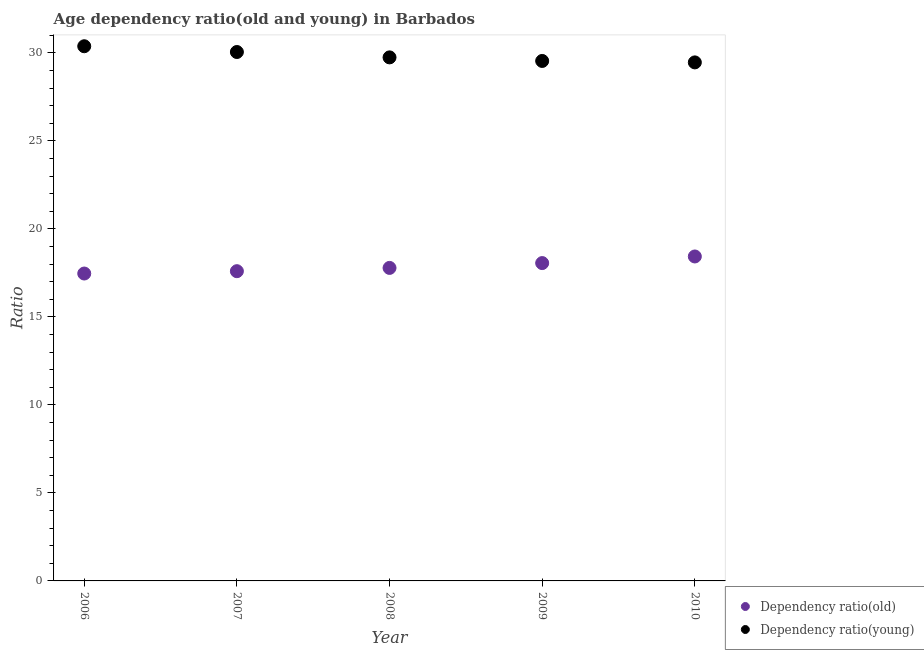Is the number of dotlines equal to the number of legend labels?
Ensure brevity in your answer.  Yes. What is the age dependency ratio(old) in 2009?
Your answer should be compact. 18.06. Across all years, what is the maximum age dependency ratio(young)?
Ensure brevity in your answer.  30.38. Across all years, what is the minimum age dependency ratio(young)?
Offer a very short reply. 29.46. What is the total age dependency ratio(old) in the graph?
Keep it short and to the point. 89.34. What is the difference between the age dependency ratio(young) in 2006 and that in 2010?
Ensure brevity in your answer.  0.92. What is the difference between the age dependency ratio(old) in 2010 and the age dependency ratio(young) in 2006?
Your answer should be compact. -11.94. What is the average age dependency ratio(old) per year?
Make the answer very short. 17.87. In the year 2009, what is the difference between the age dependency ratio(old) and age dependency ratio(young)?
Offer a terse response. -11.48. What is the ratio of the age dependency ratio(young) in 2007 to that in 2010?
Ensure brevity in your answer.  1.02. What is the difference between the highest and the second highest age dependency ratio(old)?
Your answer should be very brief. 0.38. What is the difference between the highest and the lowest age dependency ratio(old)?
Your answer should be compact. 0.97. Is the sum of the age dependency ratio(old) in 2006 and 2008 greater than the maximum age dependency ratio(young) across all years?
Provide a succinct answer. Yes. Does the age dependency ratio(old) monotonically increase over the years?
Your response must be concise. Yes. Is the age dependency ratio(old) strictly greater than the age dependency ratio(young) over the years?
Provide a short and direct response. No. Is the age dependency ratio(old) strictly less than the age dependency ratio(young) over the years?
Offer a terse response. Yes. How many years are there in the graph?
Ensure brevity in your answer.  5. What is the difference between two consecutive major ticks on the Y-axis?
Provide a short and direct response. 5. Does the graph contain grids?
Provide a succinct answer. No. How are the legend labels stacked?
Make the answer very short. Vertical. What is the title of the graph?
Provide a short and direct response. Age dependency ratio(old and young) in Barbados. What is the label or title of the Y-axis?
Provide a succinct answer. Ratio. What is the Ratio of Dependency ratio(old) in 2006?
Keep it short and to the point. 17.47. What is the Ratio of Dependency ratio(young) in 2006?
Give a very brief answer. 30.38. What is the Ratio in Dependency ratio(old) in 2007?
Your response must be concise. 17.6. What is the Ratio in Dependency ratio(young) in 2007?
Make the answer very short. 30.05. What is the Ratio of Dependency ratio(old) in 2008?
Keep it short and to the point. 17.78. What is the Ratio of Dependency ratio(young) in 2008?
Your answer should be very brief. 29.75. What is the Ratio in Dependency ratio(old) in 2009?
Provide a succinct answer. 18.06. What is the Ratio of Dependency ratio(young) in 2009?
Offer a terse response. 29.54. What is the Ratio of Dependency ratio(old) in 2010?
Your answer should be compact. 18.43. What is the Ratio in Dependency ratio(young) in 2010?
Provide a short and direct response. 29.46. Across all years, what is the maximum Ratio in Dependency ratio(old)?
Ensure brevity in your answer.  18.43. Across all years, what is the maximum Ratio of Dependency ratio(young)?
Offer a very short reply. 30.38. Across all years, what is the minimum Ratio of Dependency ratio(old)?
Your answer should be compact. 17.47. Across all years, what is the minimum Ratio of Dependency ratio(young)?
Provide a succinct answer. 29.46. What is the total Ratio of Dependency ratio(old) in the graph?
Offer a very short reply. 89.34. What is the total Ratio of Dependency ratio(young) in the graph?
Your answer should be very brief. 149.18. What is the difference between the Ratio in Dependency ratio(old) in 2006 and that in 2007?
Provide a short and direct response. -0.13. What is the difference between the Ratio of Dependency ratio(young) in 2006 and that in 2007?
Your answer should be very brief. 0.33. What is the difference between the Ratio of Dependency ratio(old) in 2006 and that in 2008?
Give a very brief answer. -0.32. What is the difference between the Ratio in Dependency ratio(young) in 2006 and that in 2008?
Your answer should be compact. 0.63. What is the difference between the Ratio in Dependency ratio(old) in 2006 and that in 2009?
Your answer should be compact. -0.59. What is the difference between the Ratio of Dependency ratio(young) in 2006 and that in 2009?
Give a very brief answer. 0.84. What is the difference between the Ratio in Dependency ratio(old) in 2006 and that in 2010?
Offer a terse response. -0.97. What is the difference between the Ratio of Dependency ratio(young) in 2006 and that in 2010?
Provide a short and direct response. 0.92. What is the difference between the Ratio of Dependency ratio(old) in 2007 and that in 2008?
Make the answer very short. -0.19. What is the difference between the Ratio in Dependency ratio(young) in 2007 and that in 2008?
Your answer should be compact. 0.31. What is the difference between the Ratio in Dependency ratio(old) in 2007 and that in 2009?
Offer a very short reply. -0.46. What is the difference between the Ratio of Dependency ratio(young) in 2007 and that in 2009?
Give a very brief answer. 0.51. What is the difference between the Ratio in Dependency ratio(old) in 2007 and that in 2010?
Provide a short and direct response. -0.84. What is the difference between the Ratio in Dependency ratio(young) in 2007 and that in 2010?
Make the answer very short. 0.59. What is the difference between the Ratio in Dependency ratio(old) in 2008 and that in 2009?
Your response must be concise. -0.27. What is the difference between the Ratio in Dependency ratio(young) in 2008 and that in 2009?
Ensure brevity in your answer.  0.2. What is the difference between the Ratio of Dependency ratio(old) in 2008 and that in 2010?
Ensure brevity in your answer.  -0.65. What is the difference between the Ratio of Dependency ratio(young) in 2008 and that in 2010?
Ensure brevity in your answer.  0.28. What is the difference between the Ratio in Dependency ratio(old) in 2009 and that in 2010?
Your answer should be compact. -0.38. What is the difference between the Ratio of Dependency ratio(young) in 2009 and that in 2010?
Offer a terse response. 0.08. What is the difference between the Ratio in Dependency ratio(old) in 2006 and the Ratio in Dependency ratio(young) in 2007?
Make the answer very short. -12.59. What is the difference between the Ratio in Dependency ratio(old) in 2006 and the Ratio in Dependency ratio(young) in 2008?
Your response must be concise. -12.28. What is the difference between the Ratio in Dependency ratio(old) in 2006 and the Ratio in Dependency ratio(young) in 2009?
Offer a terse response. -12.08. What is the difference between the Ratio in Dependency ratio(old) in 2006 and the Ratio in Dependency ratio(young) in 2010?
Provide a succinct answer. -12. What is the difference between the Ratio of Dependency ratio(old) in 2007 and the Ratio of Dependency ratio(young) in 2008?
Keep it short and to the point. -12.15. What is the difference between the Ratio of Dependency ratio(old) in 2007 and the Ratio of Dependency ratio(young) in 2009?
Give a very brief answer. -11.95. What is the difference between the Ratio of Dependency ratio(old) in 2007 and the Ratio of Dependency ratio(young) in 2010?
Keep it short and to the point. -11.86. What is the difference between the Ratio in Dependency ratio(old) in 2008 and the Ratio in Dependency ratio(young) in 2009?
Provide a short and direct response. -11.76. What is the difference between the Ratio of Dependency ratio(old) in 2008 and the Ratio of Dependency ratio(young) in 2010?
Provide a short and direct response. -11.68. What is the difference between the Ratio in Dependency ratio(old) in 2009 and the Ratio in Dependency ratio(young) in 2010?
Ensure brevity in your answer.  -11.4. What is the average Ratio of Dependency ratio(old) per year?
Your answer should be compact. 17.87. What is the average Ratio of Dependency ratio(young) per year?
Offer a terse response. 29.84. In the year 2006, what is the difference between the Ratio in Dependency ratio(old) and Ratio in Dependency ratio(young)?
Offer a very short reply. -12.91. In the year 2007, what is the difference between the Ratio of Dependency ratio(old) and Ratio of Dependency ratio(young)?
Your answer should be compact. -12.45. In the year 2008, what is the difference between the Ratio of Dependency ratio(old) and Ratio of Dependency ratio(young)?
Give a very brief answer. -11.96. In the year 2009, what is the difference between the Ratio of Dependency ratio(old) and Ratio of Dependency ratio(young)?
Your answer should be compact. -11.48. In the year 2010, what is the difference between the Ratio of Dependency ratio(old) and Ratio of Dependency ratio(young)?
Your answer should be compact. -11.03. What is the ratio of the Ratio in Dependency ratio(old) in 2006 to that in 2007?
Your answer should be very brief. 0.99. What is the ratio of the Ratio of Dependency ratio(young) in 2006 to that in 2007?
Keep it short and to the point. 1.01. What is the ratio of the Ratio of Dependency ratio(old) in 2006 to that in 2008?
Your response must be concise. 0.98. What is the ratio of the Ratio in Dependency ratio(young) in 2006 to that in 2008?
Offer a terse response. 1.02. What is the ratio of the Ratio in Dependency ratio(old) in 2006 to that in 2009?
Make the answer very short. 0.97. What is the ratio of the Ratio in Dependency ratio(young) in 2006 to that in 2009?
Provide a short and direct response. 1.03. What is the ratio of the Ratio of Dependency ratio(young) in 2006 to that in 2010?
Provide a succinct answer. 1.03. What is the ratio of the Ratio of Dependency ratio(young) in 2007 to that in 2008?
Make the answer very short. 1.01. What is the ratio of the Ratio in Dependency ratio(old) in 2007 to that in 2009?
Your response must be concise. 0.97. What is the ratio of the Ratio in Dependency ratio(young) in 2007 to that in 2009?
Offer a terse response. 1.02. What is the ratio of the Ratio of Dependency ratio(old) in 2007 to that in 2010?
Give a very brief answer. 0.95. What is the ratio of the Ratio in Dependency ratio(old) in 2008 to that in 2010?
Give a very brief answer. 0.96. What is the ratio of the Ratio in Dependency ratio(young) in 2008 to that in 2010?
Give a very brief answer. 1.01. What is the ratio of the Ratio in Dependency ratio(old) in 2009 to that in 2010?
Your answer should be very brief. 0.98. What is the difference between the highest and the second highest Ratio of Dependency ratio(old)?
Your answer should be very brief. 0.38. What is the difference between the highest and the second highest Ratio in Dependency ratio(young)?
Make the answer very short. 0.33. What is the difference between the highest and the lowest Ratio of Dependency ratio(young)?
Provide a short and direct response. 0.92. 